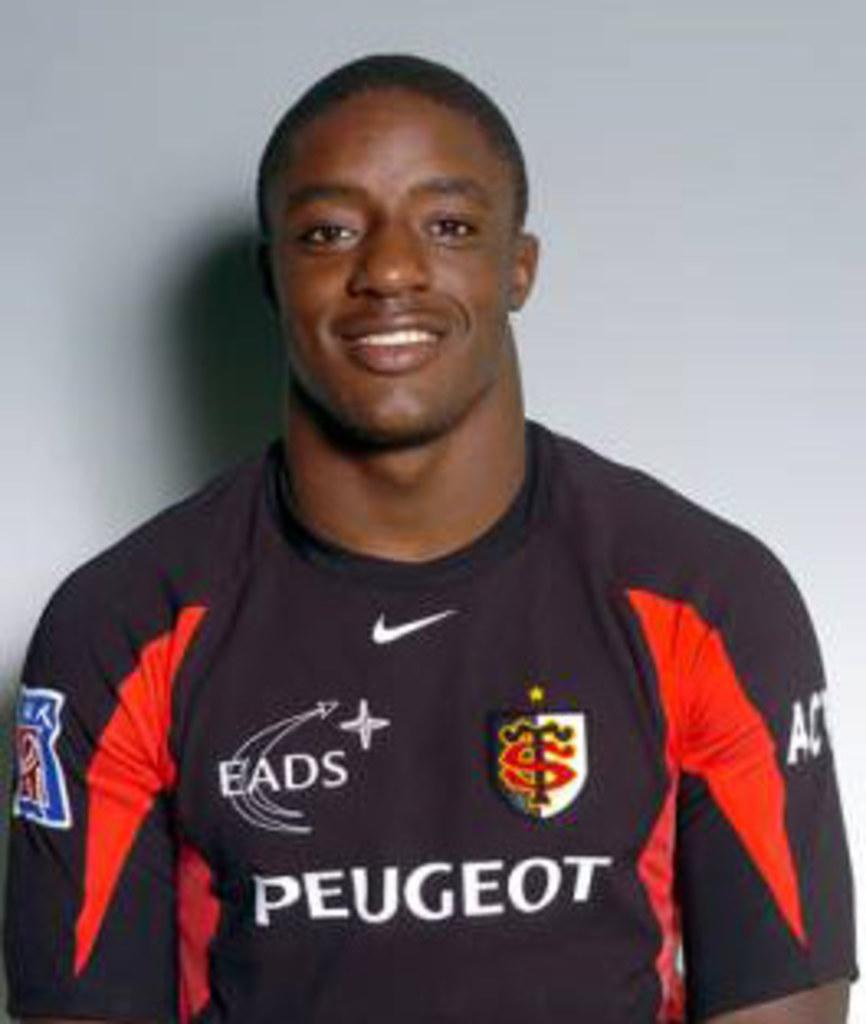<image>
Summarize the visual content of the image. A closeup photo of a playe rin a soccer jersey sponsored by Peugeot. 